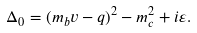Convert formula to latex. <formula><loc_0><loc_0><loc_500><loc_500>\Delta _ { 0 } = ( m _ { b } v - q ) ^ { 2 } - m _ { c } ^ { 2 } + i \varepsilon .</formula> 